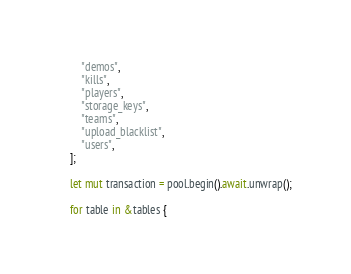Convert code to text. <code><loc_0><loc_0><loc_500><loc_500><_Rust_>        "demos",
        "kills",
        "players",
        "storage_keys",
        "teams",
        "upload_blacklist",
        "users",
    ];

    let mut transaction = pool.begin().await.unwrap();

    for table in &tables {</code> 